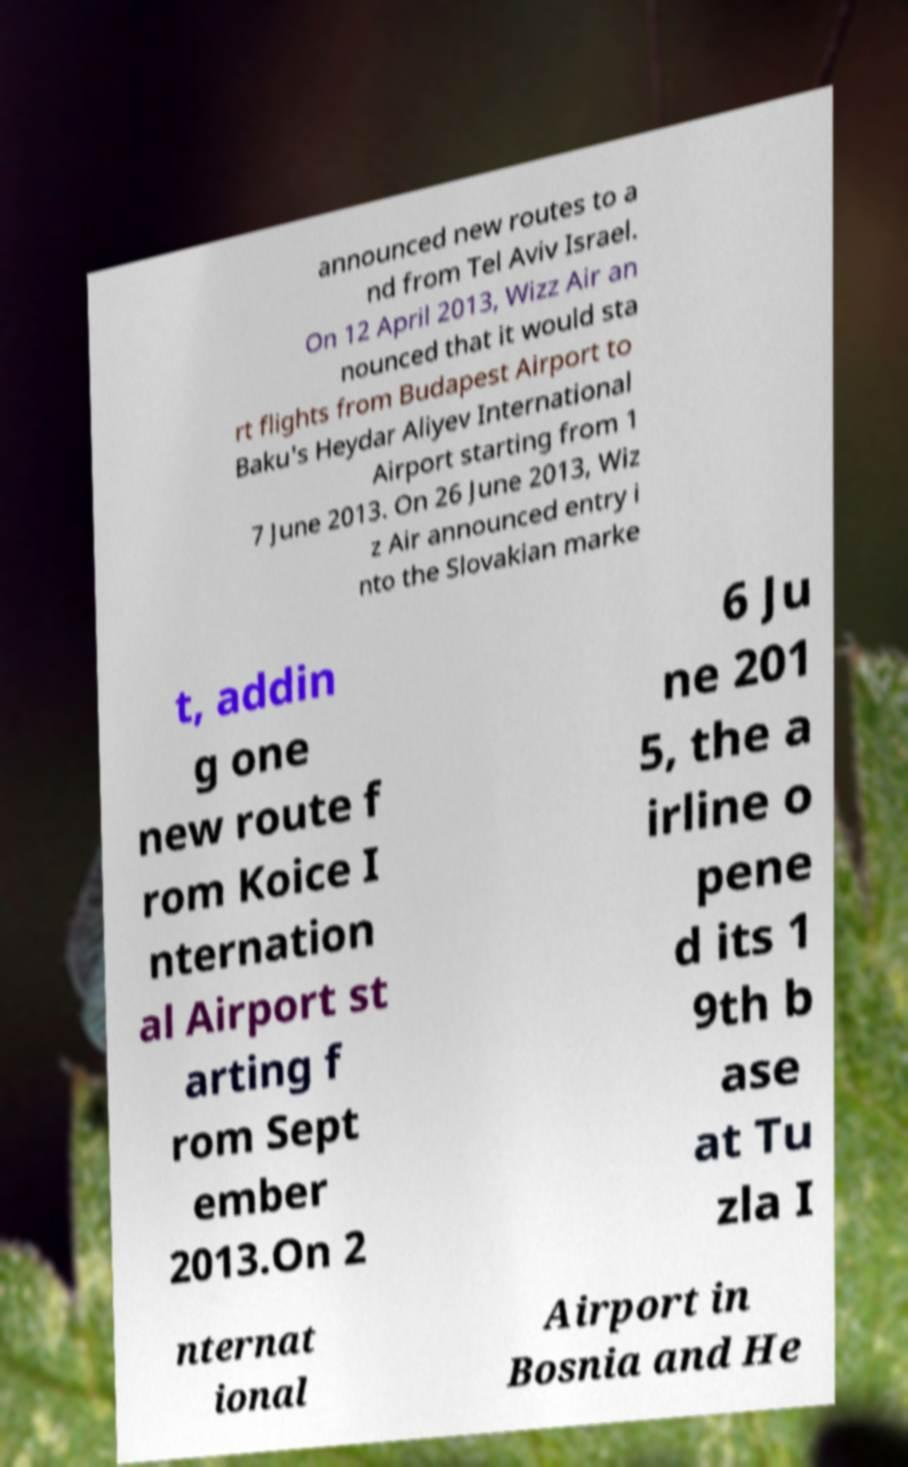For documentation purposes, I need the text within this image transcribed. Could you provide that? announced new routes to a nd from Tel Aviv Israel. On 12 April 2013, Wizz Air an nounced that it would sta rt flights from Budapest Airport to Baku's Heydar Aliyev International Airport starting from 1 7 June 2013. On 26 June 2013, Wiz z Air announced entry i nto the Slovakian marke t, addin g one new route f rom Koice I nternation al Airport st arting f rom Sept ember 2013.On 2 6 Ju ne 201 5, the a irline o pene d its 1 9th b ase at Tu zla I nternat ional Airport in Bosnia and He 